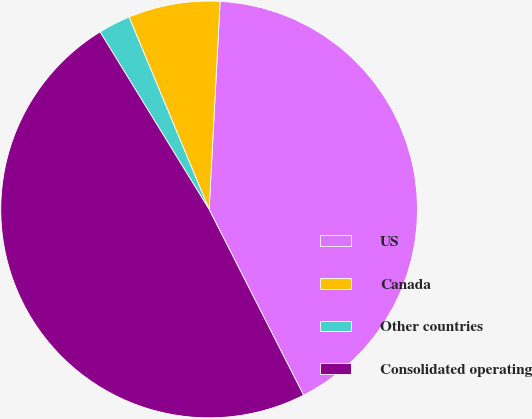<chart> <loc_0><loc_0><loc_500><loc_500><pie_chart><fcel>US<fcel>Canada<fcel>Other countries<fcel>Consolidated operating<nl><fcel>41.67%<fcel>7.12%<fcel>2.49%<fcel>48.72%<nl></chart> 